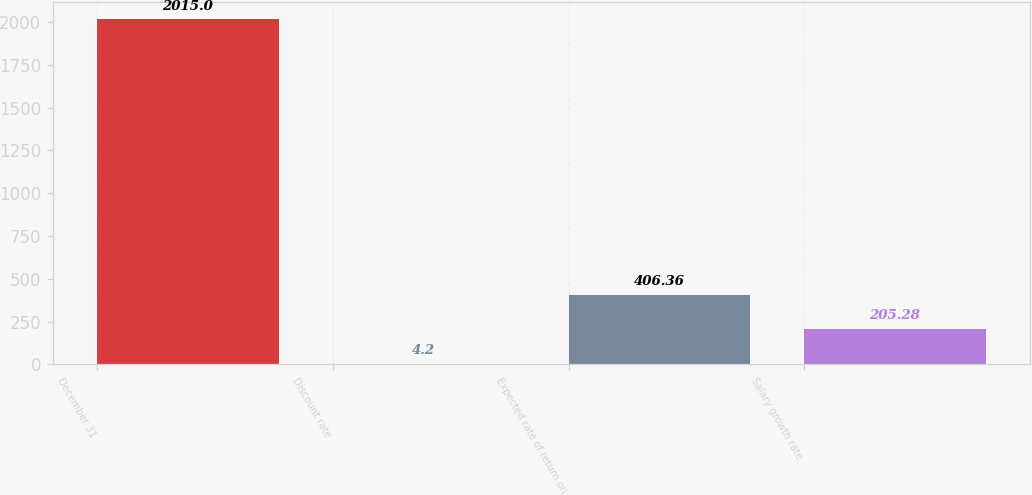<chart> <loc_0><loc_0><loc_500><loc_500><bar_chart><fcel>December 31<fcel>Discount rate<fcel>Expected rate of return on<fcel>Salary growth rate<nl><fcel>2015<fcel>4.2<fcel>406.36<fcel>205.28<nl></chart> 